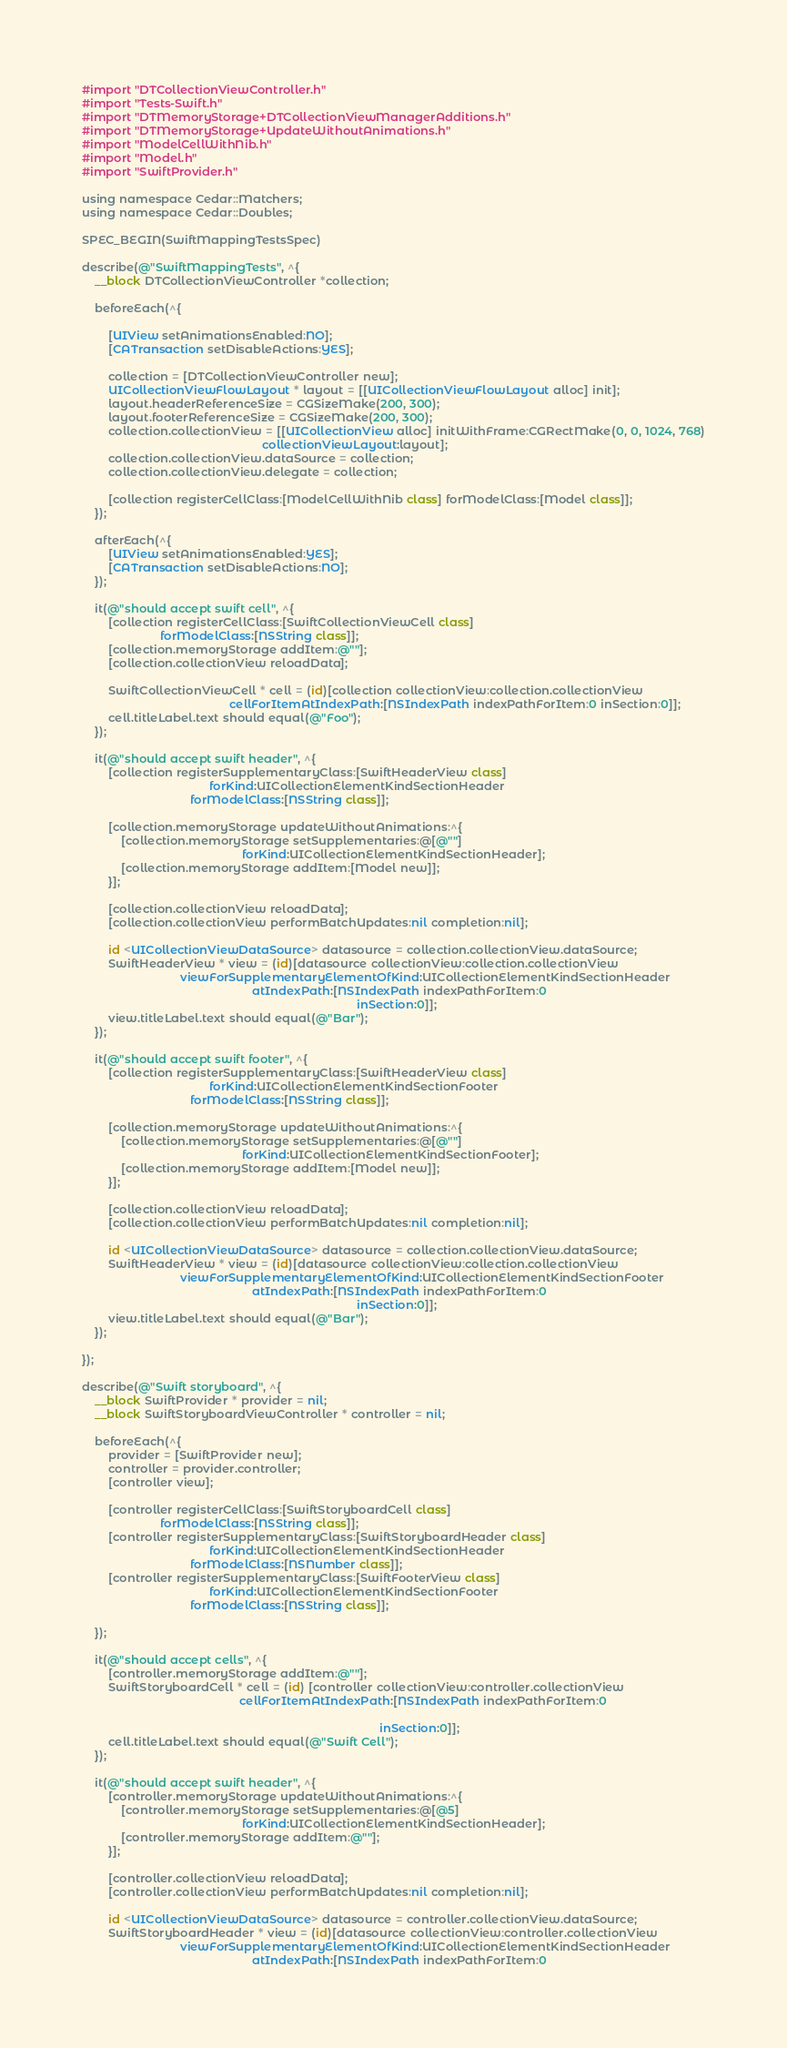Convert code to text. <code><loc_0><loc_0><loc_500><loc_500><_ObjectiveC_>#import "DTCollectionViewController.h"
#import "Tests-Swift.h"
#import "DTMemoryStorage+DTCollectionViewManagerAdditions.h"
#import "DTMemoryStorage+UpdateWithoutAnimations.h"
#import "ModelCellWithNib.h"
#import "Model.h"
#import "SwiftProvider.h"

using namespace Cedar::Matchers;
using namespace Cedar::Doubles;

SPEC_BEGIN(SwiftMappingTestsSpec)

describe(@"SwiftMappingTests", ^{
    __block DTCollectionViewController *collection;
    
    beforeEach(^{
        
        [UIView setAnimationsEnabled:NO];
        [CATransaction setDisableActions:YES];
        
        collection = [DTCollectionViewController new];
        UICollectionViewFlowLayout * layout = [[UICollectionViewFlowLayout alloc] init];
        layout.headerReferenceSize = CGSizeMake(200, 300);
        layout.footerReferenceSize = CGSizeMake(200, 300);
        collection.collectionView = [[UICollectionView alloc] initWithFrame:CGRectMake(0, 0, 1024, 768)
                                                       collectionViewLayout:layout];
        collection.collectionView.dataSource = collection;
        collection.collectionView.delegate = collection;
        
        [collection registerCellClass:[ModelCellWithNib class] forModelClass:[Model class]];
    });
    
    afterEach(^{
        [UIView setAnimationsEnabled:YES];
        [CATransaction setDisableActions:NO];
    });
    
    it(@"should accept swift cell", ^{
        [collection registerCellClass:[SwiftCollectionViewCell class]
                        forModelClass:[NSString class]];
        [collection.memoryStorage addItem:@""];
        [collection.collectionView reloadData];
        
        SwiftCollectionViewCell * cell = (id)[collection collectionView:collection.collectionView
                                             cellForItemAtIndexPath:[NSIndexPath indexPathForItem:0 inSection:0]];
        cell.titleLabel.text should equal(@"Foo");
    });
    
    it(@"should accept swift header", ^{
        [collection registerSupplementaryClass:[SwiftHeaderView class]
                                       forKind:UICollectionElementKindSectionHeader
                                 forModelClass:[NSString class]];
        
        [collection.memoryStorage updateWithoutAnimations:^{
            [collection.memoryStorage setSupplementaries:@[@""]
                                                 forKind:UICollectionElementKindSectionHeader];
            [collection.memoryStorage addItem:[Model new]];
        }];
        
        [collection.collectionView reloadData];
        [collection.collectionView performBatchUpdates:nil completion:nil];
        
        id <UICollectionViewDataSource> datasource = collection.collectionView.dataSource;
        SwiftHeaderView * view = (id)[datasource collectionView:collection.collectionView
                              viewForSupplementaryElementOfKind:UICollectionElementKindSectionHeader
                                                    atIndexPath:[NSIndexPath indexPathForItem:0
                                                                                    inSection:0]];
        view.titleLabel.text should equal(@"Bar");
    });
    
    it(@"should accept swift footer", ^{
        [collection registerSupplementaryClass:[SwiftHeaderView class]
                                       forKind:UICollectionElementKindSectionFooter
                                 forModelClass:[NSString class]];
        
        [collection.memoryStorage updateWithoutAnimations:^{
            [collection.memoryStorage setSupplementaries:@[@""]
                                                 forKind:UICollectionElementKindSectionFooter];
            [collection.memoryStorage addItem:[Model new]];
        }];
        
        [collection.collectionView reloadData];
        [collection.collectionView performBatchUpdates:nil completion:nil];
        
        id <UICollectionViewDataSource> datasource = collection.collectionView.dataSource;
        SwiftHeaderView * view = (id)[datasource collectionView:collection.collectionView
                              viewForSupplementaryElementOfKind:UICollectionElementKindSectionFooter
                                                    atIndexPath:[NSIndexPath indexPathForItem:0
                                                                                    inSection:0]];
        view.titleLabel.text should equal(@"Bar");
    });
    
});

describe(@"Swift storyboard", ^{
    __block SwiftProvider * provider = nil;
    __block SwiftStoryboardViewController * controller = nil;
    
    beforeEach(^{
        provider = [SwiftProvider new];
        controller = provider.controller;
        [controller view];
        
        [controller registerCellClass:[SwiftStoryboardCell class]
                        forModelClass:[NSString class]];
        [controller registerSupplementaryClass:[SwiftStoryboardHeader class]
                                       forKind:UICollectionElementKindSectionHeader
                                 forModelClass:[NSNumber class]];
        [controller registerSupplementaryClass:[SwiftFooterView class]
                                       forKind:UICollectionElementKindSectionFooter
                                 forModelClass:[NSString class]];
        
    });
    
    it(@"should accept cells", ^{
        [controller.memoryStorage addItem:@""];
        SwiftStoryboardCell * cell = (id) [controller collectionView:controller.collectionView
                                                cellForItemAtIndexPath:[NSIndexPath indexPathForItem:0
                                                                        
                                                                                           inSection:0]];
        cell.titleLabel.text should equal(@"Swift Cell");
    });
    
    it(@"should accept swift header", ^{
        [controller.memoryStorage updateWithoutAnimations:^{
            [controller.memoryStorage setSupplementaries:@[@5]
                                                 forKind:UICollectionElementKindSectionHeader];
            [controller.memoryStorage addItem:@""];
        }];
        
        [controller.collectionView reloadData];
        [controller.collectionView performBatchUpdates:nil completion:nil];
        
        id <UICollectionViewDataSource> datasource = controller.collectionView.dataSource;
        SwiftStoryboardHeader * view = (id)[datasource collectionView:controller.collectionView
                              viewForSupplementaryElementOfKind:UICollectionElementKindSectionHeader
                                                    atIndexPath:[NSIndexPath indexPathForItem:0</code> 